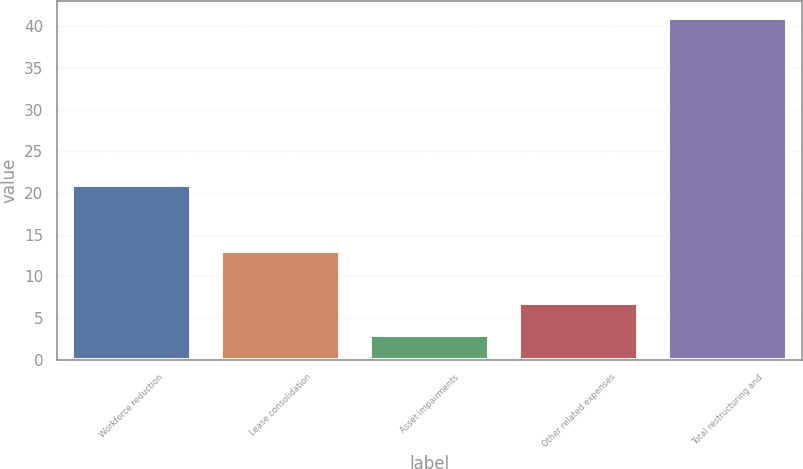Convert chart to OTSL. <chart><loc_0><loc_0><loc_500><loc_500><bar_chart><fcel>Workforce reduction<fcel>Lease consolidation<fcel>Asset impairments<fcel>Other related expenses<fcel>Total restructuring and<nl><fcel>21<fcel>13<fcel>3<fcel>6.8<fcel>41<nl></chart> 